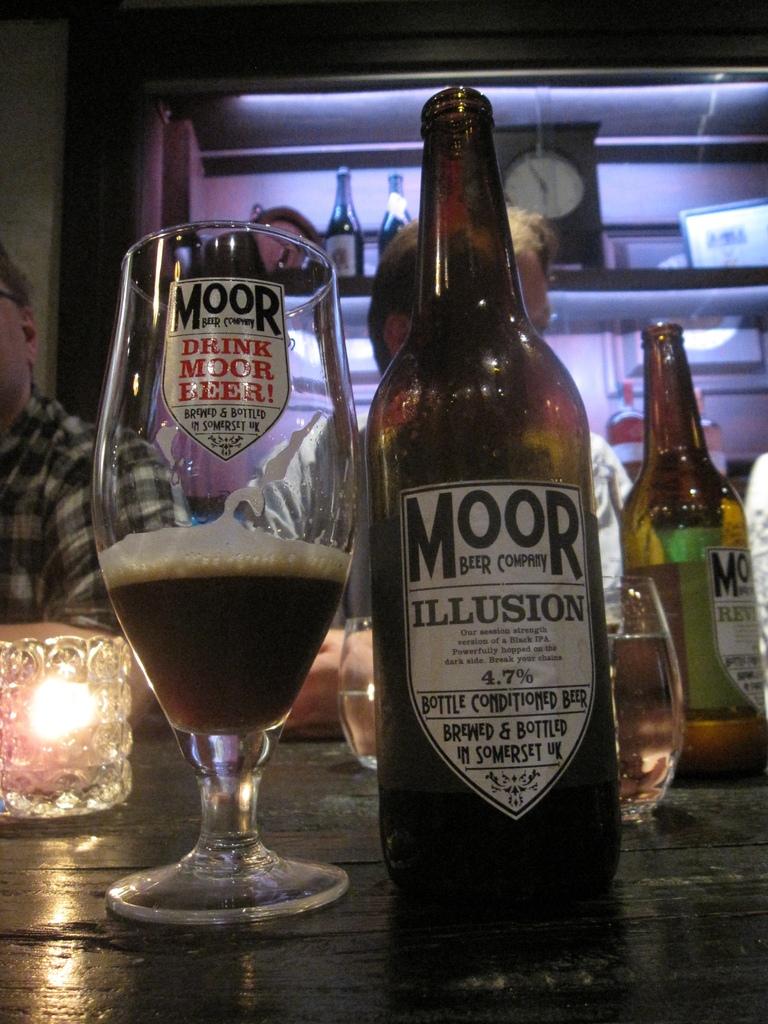What is the brand?
Offer a very short reply. Moor. 